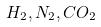<formula> <loc_0><loc_0><loc_500><loc_500>H _ { 2 } , N _ { 2 } , C O _ { 2 }</formula> 